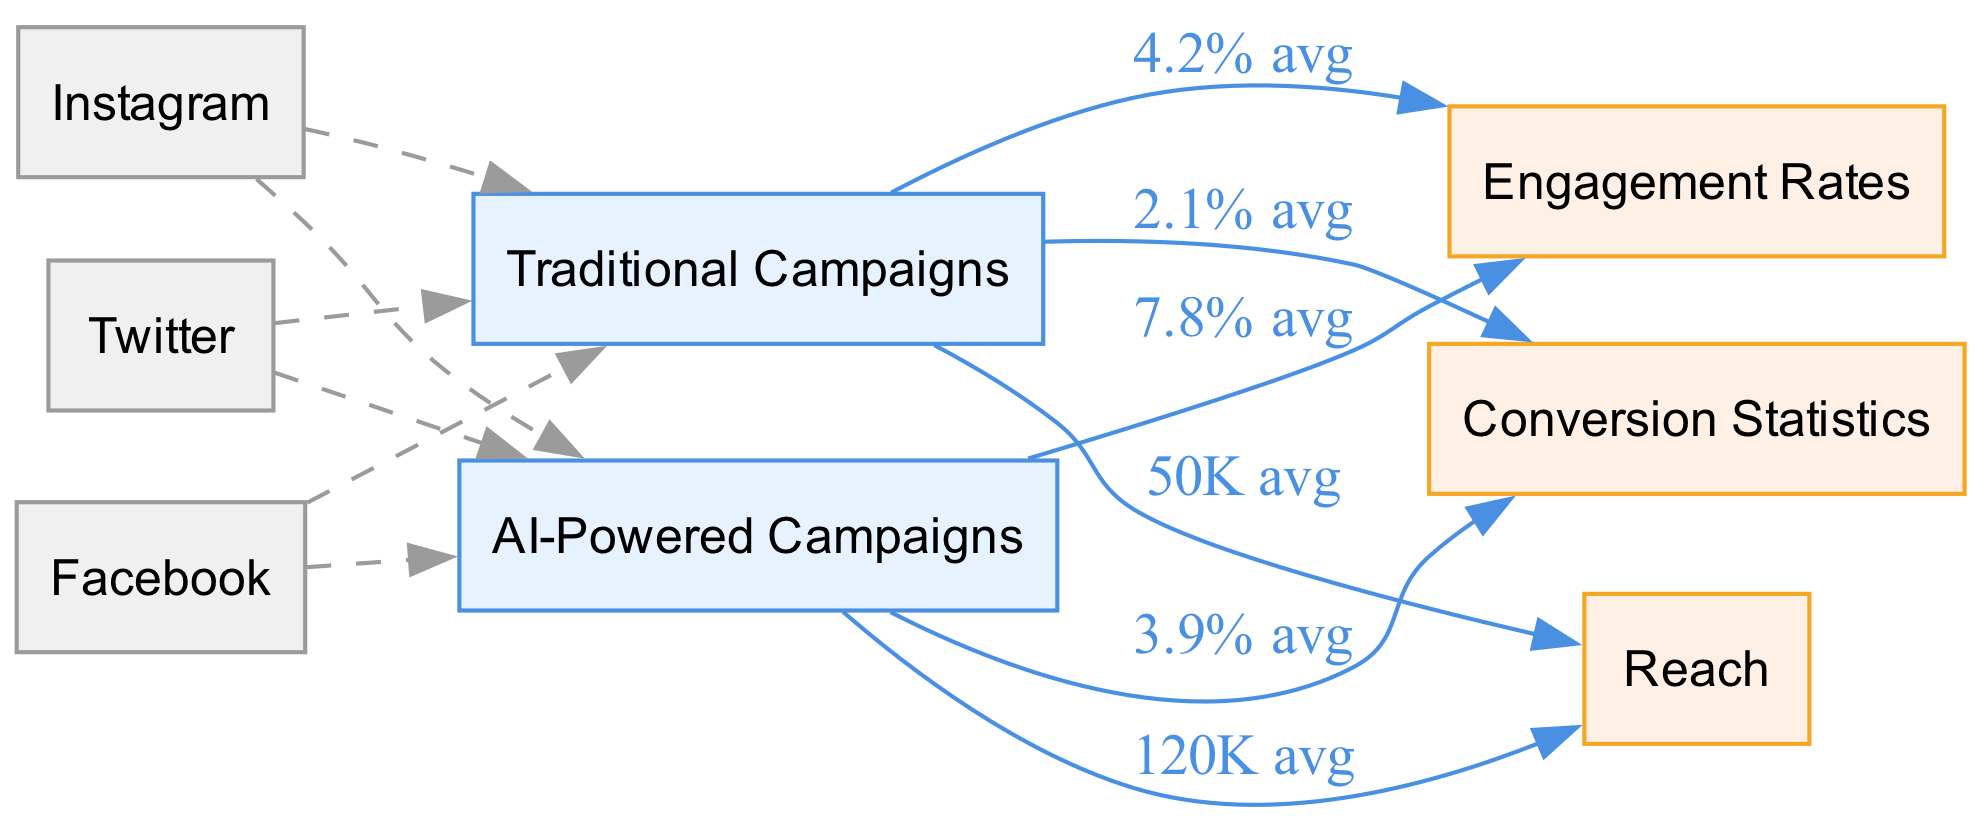What is the average engagement rate for traditional campaigns? According to the diagram, the edge from "Traditional Campaigns" to "Engagement Rates" shows an average engagement rate of 4.2%.
Answer: 4.2% What is the average reach for AI-powered campaigns? The edge from "AI-Powered Campaigns" to "Reach" indicates an average reach of 120K.
Answer: 120K How much higher is the engagement rate for AI-powered campaigns compared to traditional campaigns? The engagement rate for AI-powered campaigns is 7.8%, while for traditional campaigns it is 4.2%. To find the difference, calculate 7.8% - 4.2% = 3.6%.
Answer: 3.6% What is the average conversion statistic for traditional campaigns? From the diagram, the edge from "Traditional Campaigns" to "Conversion Statistics" specifies an average conversion rate of 2.1%.
Answer: 2.1% Which campaign type indicates a higher average reach, traditional or AI-powered? The average reach for AI-powered campaigns (120K) exceeds that of traditional campaigns (50K). The information can be obtained by comparing the directed edges for reach in the diagram.
Answer: AI-Powered Campaigns How does the average conversion statistic for AI-powered campaigns compare to traditional ones? The average conversion statistic for AI-powered campaigns is 3.9%, while traditional campaigns show 2.1%. Thus, the AI-powered statistic is higher by 3.9% - 2.1% = 1.8%.
Answer: Higher by 1.8% What is the average engagement rate for AI-powered campaigns? Looking at the edge from "AI-Powered Campaigns" to "Engagement Rates," the average engagement rate is indicated as 7.8%.
Answer: 7.8% How many nodes are dedicated to social media platforms in the diagram? The diagram features three nodes representing social media platforms: Instagram, Facebook, and Twitter. Therefore, the count of dedicated social media platform nodes is three.
Answer: 3 Which campaign type has a greater average conversion rate based on the diagram? By examining the edges, the AI-powered campaign's average conversion rate (3.9%) is greater than that of traditional campaigns (2.1%). The comparison clearly shows which campaign type performs better in conversion.
Answer: AI-Powered Campaigns What type of campaigns has a reach of 50K? The reach of 50K is specified for traditional campaigns as seen in the diagram from the edge leading from "Traditional Campaigns" to "Reach."
Answer: Traditional Campaigns 